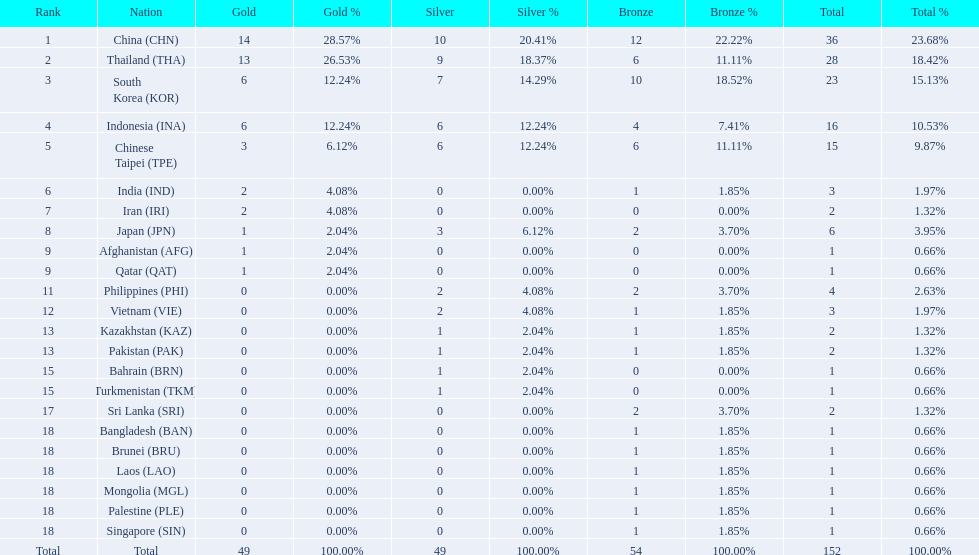How many nations won no silver medals at all? 11. 